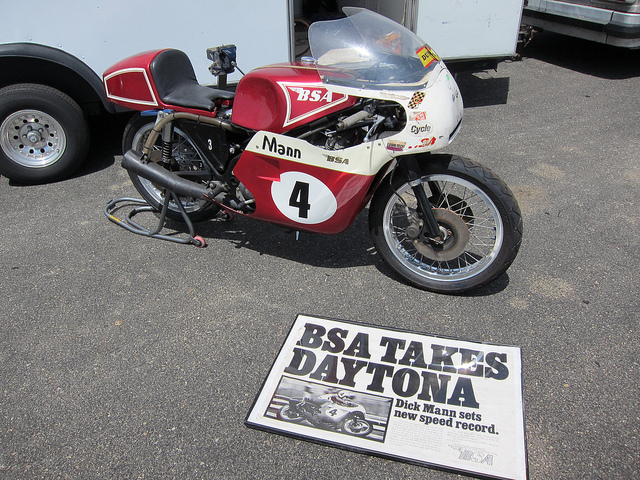Read all the text in this image. BSA Mann BSA 4 BSA 3 DAYTONA tAKES TONA record. speed new sets Mann Dick 